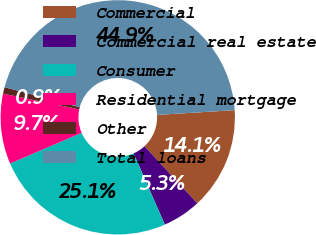Convert chart to OTSL. <chart><loc_0><loc_0><loc_500><loc_500><pie_chart><fcel>Commercial<fcel>Commercial real estate<fcel>Consumer<fcel>Residential mortgage<fcel>Other<fcel>Total loans<nl><fcel>14.09%<fcel>5.3%<fcel>25.13%<fcel>9.69%<fcel>0.9%<fcel>44.88%<nl></chart> 